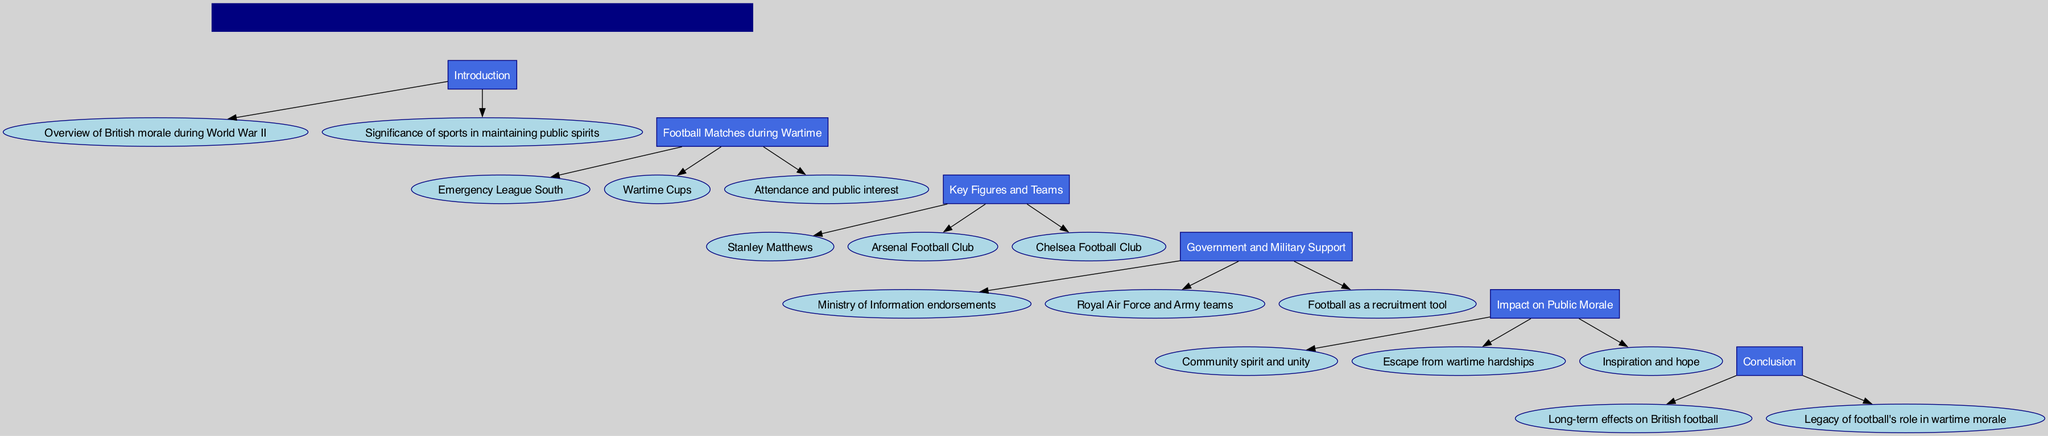What is the title of the diagram? The title node states the title of the diagram, which is clearly labeled at the top. It outlines the main theme of the diagram without any ambiguity.
Answer: The Role of Football during Wartime: Uplifting British Morale in World War II How many blocks are in the diagram? The diagram contains six main blocks that sequentially present different aspects of the topic. Each block is distinctly labeled and contains content related to its title.
Answer: 6 What is the first topic covered in the block diagram? The first block of the diagram is titled "Introduction," indicating that it covers fundamental aspects of the subject before moving on to specific details.
Answer: Introduction Which football clubs are mentioned in the diagram? In the "Key Figures and Teams" block, both Arsenal Football Club and Chelsea Football Club are listed, highlighting their relevance during wartime football.
Answer: Arsenal Football Club, Chelsea Football Club What role did the Ministry of Information play according to the diagram? The "Government and Military Support" block specifies that the Ministry of Information provided endorsements, showcasing its direct involvement in promoting football during the war.
Answer: Endorsements What was one impact of football highlighted in the diagram? The "Impact on Public Morale" block includes elements such as community spirit and unity, demonstrating how football contributed positively to the morale during wartime.
Answer: Community spirit and unity Which key figure is specifically noted in the diagram? The diagram features Stanley Matthews in the "Key Figures and Teams" block, emphasizing his significance in the context of football during the war.
Answer: Stanley Matthews What does the diagram suggest about football's role as a recruitment tool? According to the "Government and Military Support" block, football served as a recruitment tool, indicating its strategic importance for military enlistment efforts.
Answer: Recruitment tool What long-term effects are mentioned in the conclusion of the diagram? The "Conclusion" block discusses long-term effects on British football, implying that wartime experiences shaped its future development and legacy.
Answer: Long-term effects on British football 